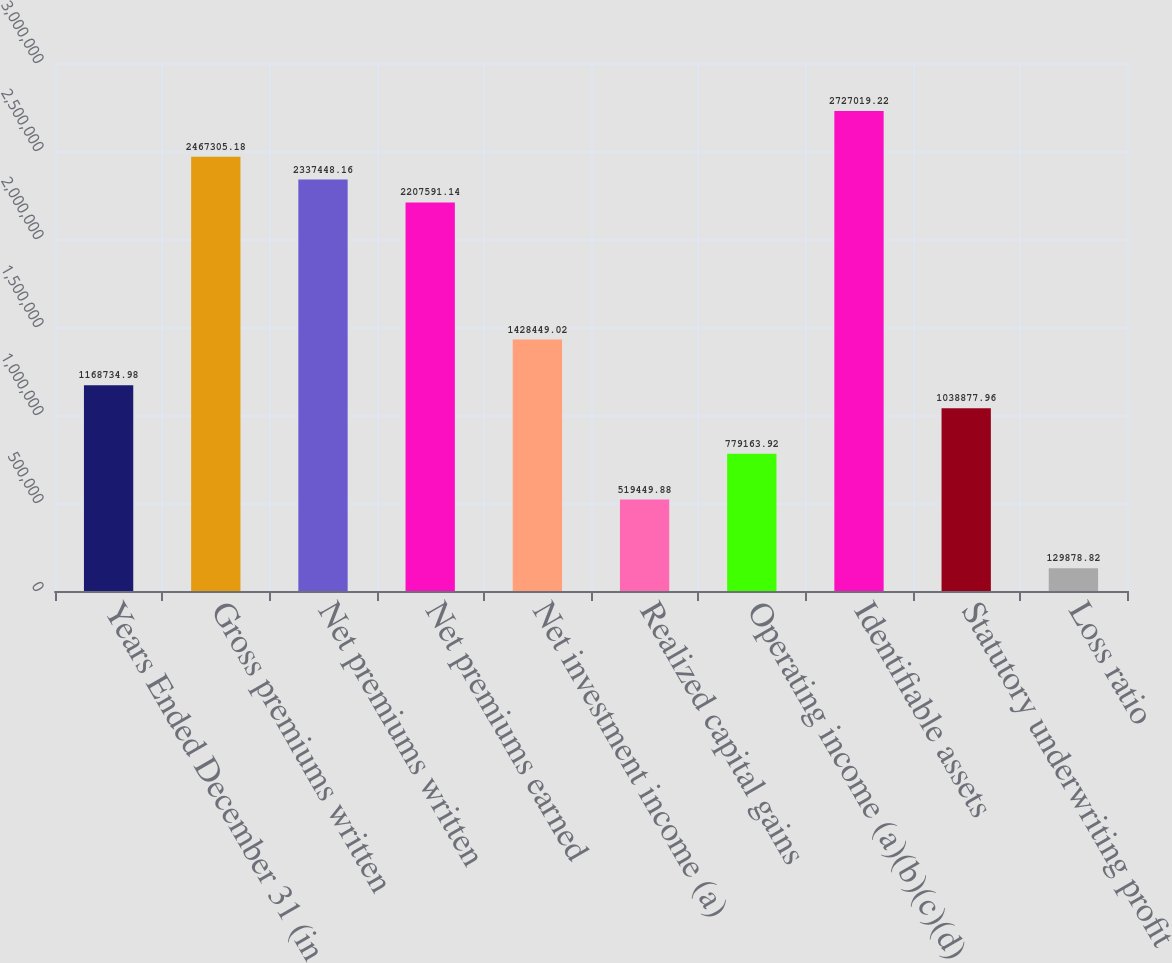Convert chart to OTSL. <chart><loc_0><loc_0><loc_500><loc_500><bar_chart><fcel>Years Ended December 31 (in<fcel>Gross premiums written<fcel>Net premiums written<fcel>Net premiums earned<fcel>Net investment income (a)<fcel>Realized capital gains<fcel>Operating income (a)(b)(c)(d)<fcel>Identifiable assets<fcel>Statutory underwriting profit<fcel>Loss ratio<nl><fcel>1.16873e+06<fcel>2.46731e+06<fcel>2.33745e+06<fcel>2.20759e+06<fcel>1.42845e+06<fcel>519450<fcel>779164<fcel>2.72702e+06<fcel>1.03888e+06<fcel>129879<nl></chart> 